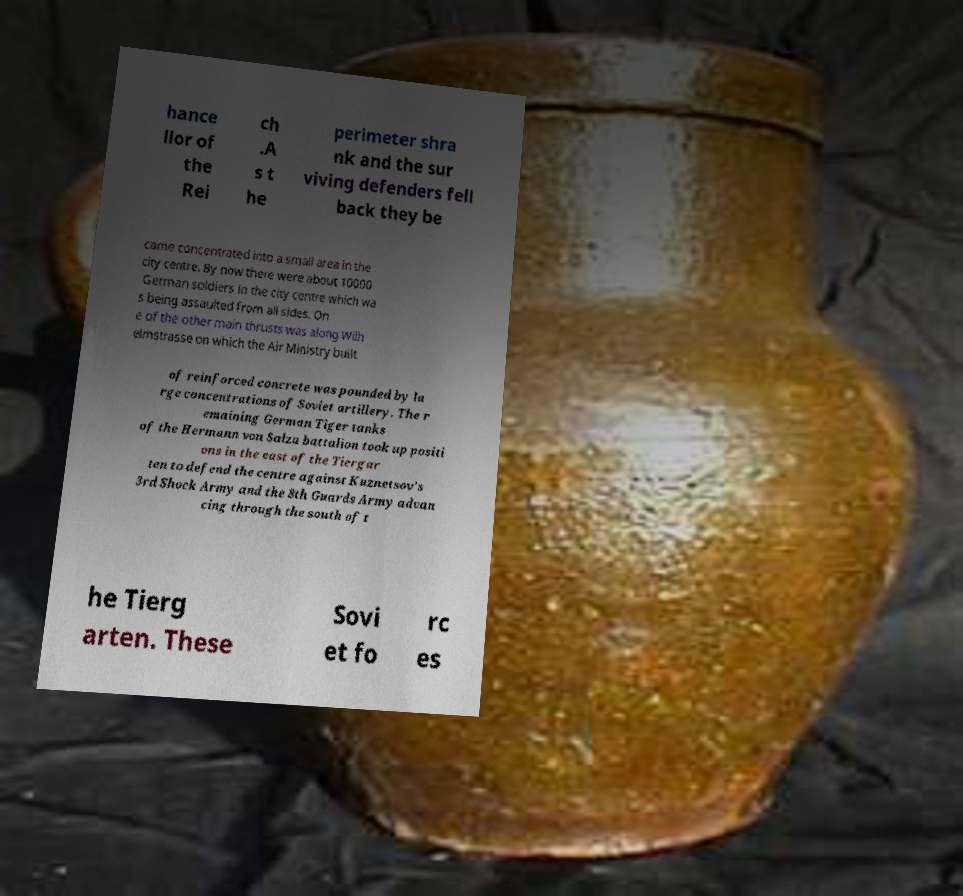Can you accurately transcribe the text from the provided image for me? hance llor of the Rei ch .A s t he perimeter shra nk and the sur viving defenders fell back they be came concentrated into a small area in the city centre. By now there were about 10000 German soldiers in the city centre which wa s being assaulted from all sides. On e of the other main thrusts was along Wilh elmstrasse on which the Air Ministry built of reinforced concrete was pounded by la rge concentrations of Soviet artillery. The r emaining German Tiger tanks of the Hermann von Salza battalion took up positi ons in the east of the Tiergar ten to defend the centre against Kuznetsov's 3rd Shock Army and the 8th Guards Army advan cing through the south of t he Tierg arten. These Sovi et fo rc es 